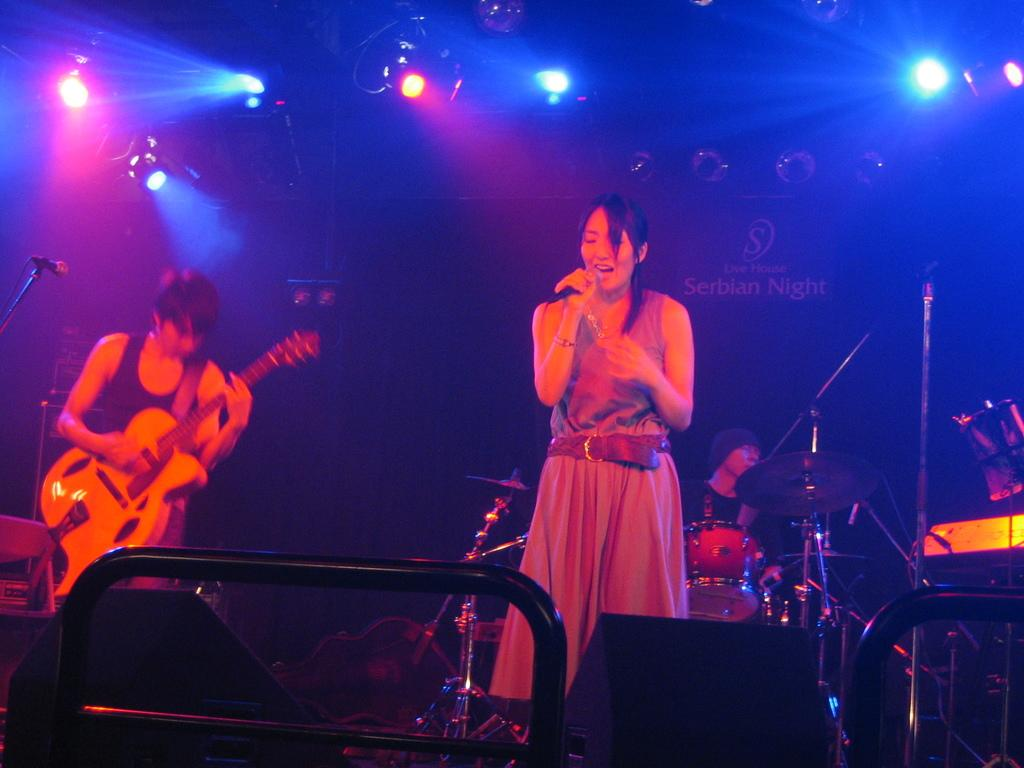How many women are in the image? There are two women in the image. What are the women doing in the image? One of the women is singing, and the other woman is playing the guitar. How is the woman who is singing holding the microphone? The woman who is singing has a microphone in her right hand. What additional feature can be seen in the image? There are disco lights visible in the image. What type of coil is being used by the secretary in the image? There is no secretary present in the image, and therefore no coil can be observed. 